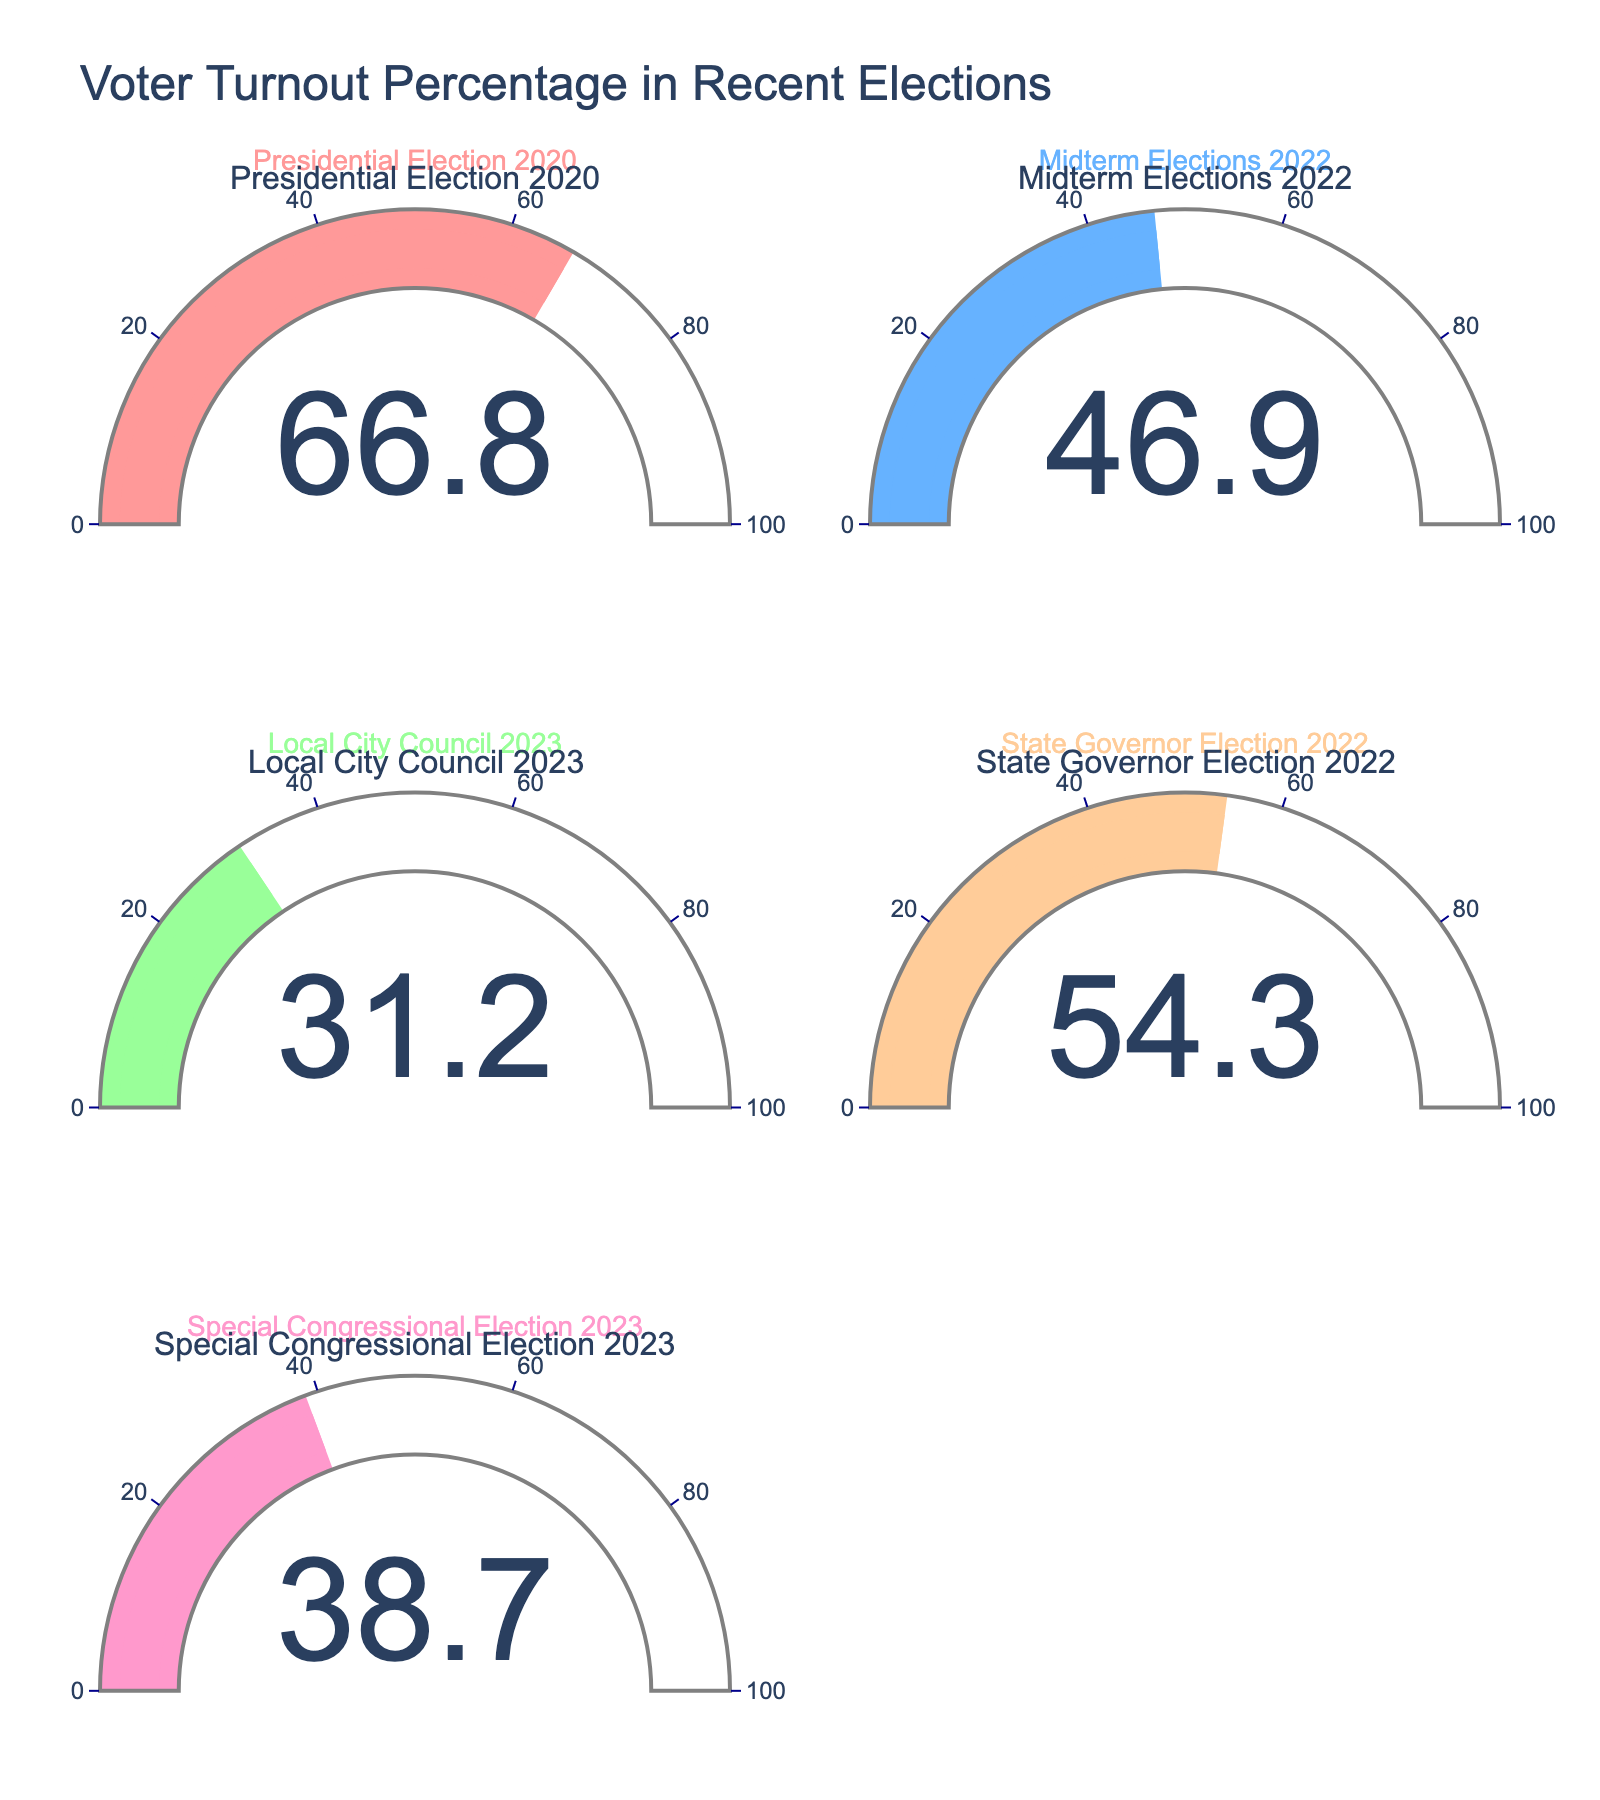what is the voter turnout for the Presidential Election 2020? The figure shows a gauge chart for the Presidential Election 2020 with a single number indicating the voter turnout percentage.
Answer: 66.8% What is the lowest voter turnout percentage displayed? By examining all the gauge charts, the Local City Council 2023 election has the lowest voter turnout.
Answer: 31.2% Which election type had the highest voter turnout? By comparing the values shown in each gauge chart, the Presidential Election 2020 had the highest voter turnout.
Answer: Presidential Election 2020 What is the difference in voter turnout between the Presidential Election 2020 and the Midterm Elections 2022? Subtract the turnout percentage of the Midterm Elections 2022 from that of the Presidential Election 2020 (66.8 - 46.9).
Answer: 19.9% What is the average voter turnout percentage across all displayed elections? Sum all voter turnout values (66.8 + 46.9 + 31.2 + 54.3 + 38.7) and divide by the number of elections (5).
Answer: 47.58% How many elections had a voter turnout above 50%? By examining the gauge charts, the Presidential Election 2020 and the State Governor Election 2022 had voter turnouts above 50%. Count these elections.
Answer: 2 What’s the voter turnout for the Special Congressional Election 2023? Refer to the gauge chart for the Special Congressional Election 2023 to find the voter turnout percentage.
Answer: 38.7% Is the voter turnout for the State Governor Election 2022 higher than the voter turnout for the Local City Council 2023 election? Compare the voter turnout percentages for the State Governor Election 2022 (54.3%) and the Local City Council 2023 election (31.2%).
Answer: Yes If the voter turnout for the Special Congressional Election 2023 increased by 10%, what would the new turnout percentage be? Add 10% to the current voter turnout of the Special Congressional Election 2023 (38.7 + 10).
Answer: 48.7% Place the elections in descending order based on their voter turnout percentages. List the voter turnout percentages for all elections and sort them from highest to lowest: [66.8, 54.3, 46.9, 38.7, 31.2].
Answer: Presidential Election 2020, State Governor Election 2022, Midterm Elections 2022, Special Congressional Election 2023, Local City Council 2023 